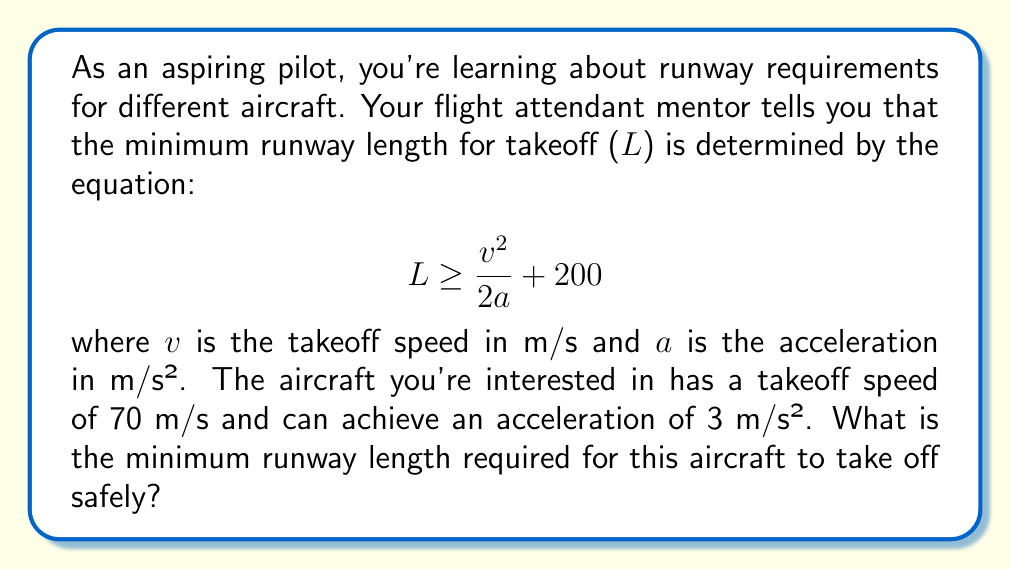Help me with this question. To solve this problem, we'll follow these steps:

1) We're given the following information:
   $v = 70$ m/s (takeoff speed)
   $a = 3$ m/s² (acceleration)

2) We need to use the inequality:
   $$L \geq \frac{v^2}{2a} + 200$$

3) Let's substitute the known values:
   $$L \geq \frac{(70)^2}{2(3)} + 200$$

4) First, calculate $v^2$:
   $$L \geq \frac{4900}{2(3)} + 200$$

5) Divide 4900 by 6:
   $$L \geq 816.67 + 200$$

6) Add 816.67 and 200:
   $$L \geq 1016.67$$

7) Since we're looking for the minimum runway length, we'll use the equality:
   $$L = 1016.67$$

8) Round up to the nearest meter for safety:
   $$L = 1017\text{ meters}$$

Therefore, the minimum runway length required for this aircraft to take off safely is 1017 meters.
Answer: The minimum runway length required is 1017 meters. 